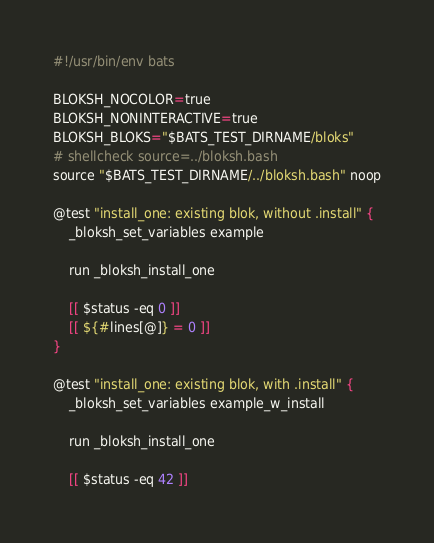<code> <loc_0><loc_0><loc_500><loc_500><_Bash_>#!/usr/bin/env bats

BLOKSH_NOCOLOR=true
BLOKSH_NONINTERACTIVE=true
BLOKSH_BLOKS="$BATS_TEST_DIRNAME/bloks"
# shellcheck source=../bloksh.bash
source "$BATS_TEST_DIRNAME/../bloksh.bash" noop

@test "install_one: existing blok, without .install" {
	_bloksh_set_variables example

	run _bloksh_install_one

	[[ $status -eq 0 ]]
	[[ ${#lines[@]} = 0 ]]
}

@test "install_one: existing blok, with .install" {
	_bloksh_set_variables example_w_install

	run _bloksh_install_one

	[[ $status -eq 42 ]]</code> 